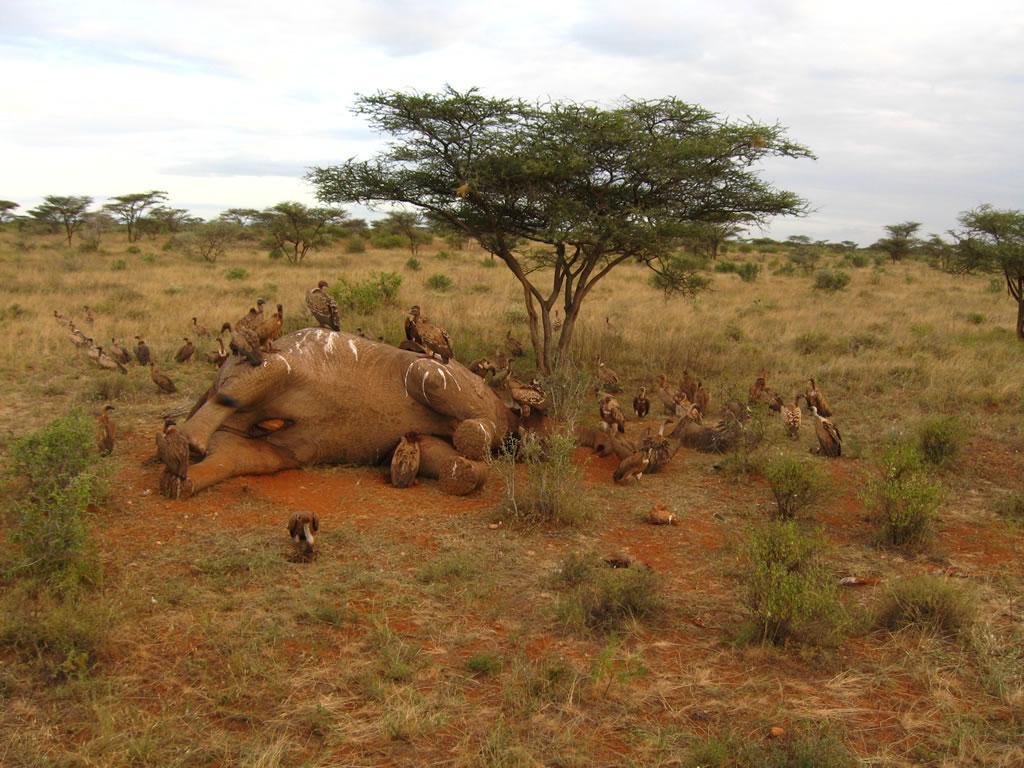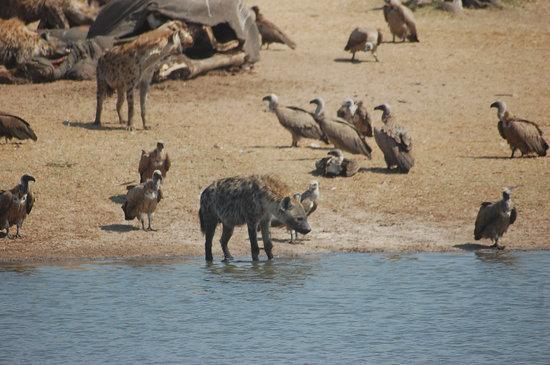The first image is the image on the left, the second image is the image on the right. For the images shown, is this caption "In the right image, at least one hyena is present along with vultures." true? Answer yes or no. Yes. The first image is the image on the left, the second image is the image on the right. Analyze the images presented: Is the assertion "there is a hyena in the image on the right." valid? Answer yes or no. Yes. 